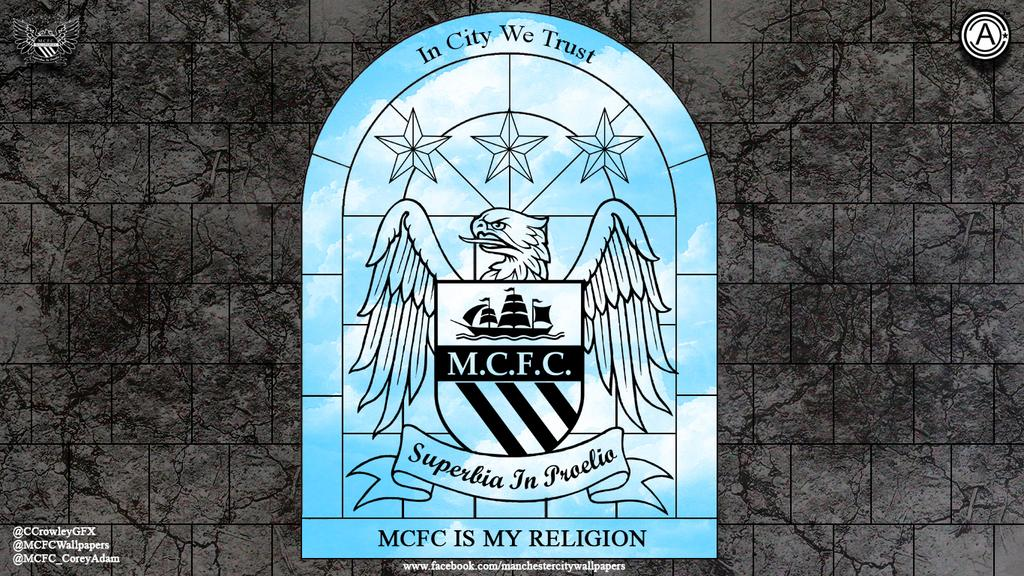<image>
Summarize the visual content of the image. a window in a room that says MCFC is my religion 